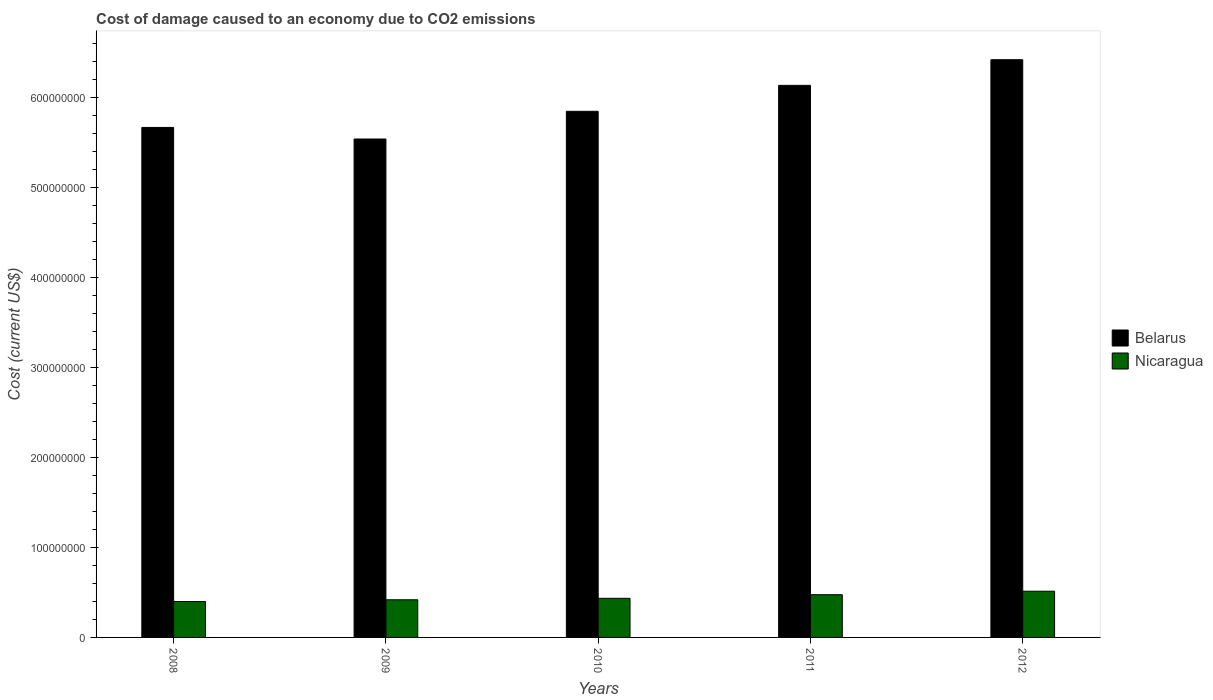How many groups of bars are there?
Give a very brief answer. 5. Are the number of bars per tick equal to the number of legend labels?
Offer a very short reply. Yes. How many bars are there on the 2nd tick from the left?
Make the answer very short. 2. In how many cases, is the number of bars for a given year not equal to the number of legend labels?
Your answer should be very brief. 0. What is the cost of damage caused due to CO2 emissisons in Nicaragua in 2011?
Your response must be concise. 4.75e+07. Across all years, what is the maximum cost of damage caused due to CO2 emissisons in Belarus?
Your answer should be very brief. 6.42e+08. Across all years, what is the minimum cost of damage caused due to CO2 emissisons in Belarus?
Your answer should be compact. 5.54e+08. In which year was the cost of damage caused due to CO2 emissisons in Nicaragua maximum?
Offer a very short reply. 2012. In which year was the cost of damage caused due to CO2 emissisons in Nicaragua minimum?
Provide a succinct answer. 2008. What is the total cost of damage caused due to CO2 emissisons in Belarus in the graph?
Offer a terse response. 2.96e+09. What is the difference between the cost of damage caused due to CO2 emissisons in Nicaragua in 2010 and that in 2011?
Offer a very short reply. -4.03e+06. What is the difference between the cost of damage caused due to CO2 emissisons in Nicaragua in 2008 and the cost of damage caused due to CO2 emissisons in Belarus in 2010?
Your answer should be very brief. -5.45e+08. What is the average cost of damage caused due to CO2 emissisons in Belarus per year?
Your answer should be compact. 5.92e+08. In the year 2008, what is the difference between the cost of damage caused due to CO2 emissisons in Belarus and cost of damage caused due to CO2 emissisons in Nicaragua?
Your answer should be very brief. 5.27e+08. In how many years, is the cost of damage caused due to CO2 emissisons in Belarus greater than 300000000 US$?
Your answer should be compact. 5. What is the ratio of the cost of damage caused due to CO2 emissisons in Nicaragua in 2008 to that in 2012?
Your answer should be compact. 0.78. Is the cost of damage caused due to CO2 emissisons in Belarus in 2009 less than that in 2010?
Make the answer very short. Yes. What is the difference between the highest and the second highest cost of damage caused due to CO2 emissisons in Belarus?
Keep it short and to the point. 2.85e+07. What is the difference between the highest and the lowest cost of damage caused due to CO2 emissisons in Belarus?
Offer a terse response. 8.81e+07. What does the 1st bar from the left in 2011 represents?
Offer a terse response. Belarus. What does the 2nd bar from the right in 2009 represents?
Make the answer very short. Belarus. How many bars are there?
Ensure brevity in your answer.  10. How many years are there in the graph?
Your response must be concise. 5. What is the difference between two consecutive major ticks on the Y-axis?
Make the answer very short. 1.00e+08. Are the values on the major ticks of Y-axis written in scientific E-notation?
Offer a terse response. No. Does the graph contain any zero values?
Offer a terse response. No. Does the graph contain grids?
Give a very brief answer. No. Where does the legend appear in the graph?
Offer a terse response. Center right. How many legend labels are there?
Offer a very short reply. 2. What is the title of the graph?
Provide a succinct answer. Cost of damage caused to an economy due to CO2 emissions. What is the label or title of the X-axis?
Offer a terse response. Years. What is the label or title of the Y-axis?
Provide a short and direct response. Cost (current US$). What is the Cost (current US$) in Belarus in 2008?
Give a very brief answer. 5.67e+08. What is the Cost (current US$) of Nicaragua in 2008?
Ensure brevity in your answer.  3.99e+07. What is the Cost (current US$) in Belarus in 2009?
Give a very brief answer. 5.54e+08. What is the Cost (current US$) of Nicaragua in 2009?
Your answer should be compact. 4.18e+07. What is the Cost (current US$) in Belarus in 2010?
Provide a short and direct response. 5.85e+08. What is the Cost (current US$) of Nicaragua in 2010?
Provide a short and direct response. 4.35e+07. What is the Cost (current US$) in Belarus in 2011?
Your response must be concise. 6.14e+08. What is the Cost (current US$) in Nicaragua in 2011?
Make the answer very short. 4.75e+07. What is the Cost (current US$) in Belarus in 2012?
Make the answer very short. 6.42e+08. What is the Cost (current US$) of Nicaragua in 2012?
Give a very brief answer. 5.14e+07. Across all years, what is the maximum Cost (current US$) of Belarus?
Give a very brief answer. 6.42e+08. Across all years, what is the maximum Cost (current US$) of Nicaragua?
Ensure brevity in your answer.  5.14e+07. Across all years, what is the minimum Cost (current US$) of Belarus?
Your answer should be very brief. 5.54e+08. Across all years, what is the minimum Cost (current US$) in Nicaragua?
Make the answer very short. 3.99e+07. What is the total Cost (current US$) of Belarus in the graph?
Ensure brevity in your answer.  2.96e+09. What is the total Cost (current US$) in Nicaragua in the graph?
Keep it short and to the point. 2.24e+08. What is the difference between the Cost (current US$) in Belarus in 2008 and that in 2009?
Offer a very short reply. 1.29e+07. What is the difference between the Cost (current US$) of Nicaragua in 2008 and that in 2009?
Make the answer very short. -1.94e+06. What is the difference between the Cost (current US$) of Belarus in 2008 and that in 2010?
Provide a succinct answer. -1.79e+07. What is the difference between the Cost (current US$) of Nicaragua in 2008 and that in 2010?
Make the answer very short. -3.55e+06. What is the difference between the Cost (current US$) of Belarus in 2008 and that in 2011?
Offer a terse response. -4.68e+07. What is the difference between the Cost (current US$) in Nicaragua in 2008 and that in 2011?
Provide a short and direct response. -7.58e+06. What is the difference between the Cost (current US$) of Belarus in 2008 and that in 2012?
Offer a very short reply. -7.53e+07. What is the difference between the Cost (current US$) of Nicaragua in 2008 and that in 2012?
Provide a succinct answer. -1.14e+07. What is the difference between the Cost (current US$) in Belarus in 2009 and that in 2010?
Offer a very short reply. -3.08e+07. What is the difference between the Cost (current US$) of Nicaragua in 2009 and that in 2010?
Your answer should be compact. -1.61e+06. What is the difference between the Cost (current US$) of Belarus in 2009 and that in 2011?
Your answer should be very brief. -5.96e+07. What is the difference between the Cost (current US$) in Nicaragua in 2009 and that in 2011?
Ensure brevity in your answer.  -5.64e+06. What is the difference between the Cost (current US$) in Belarus in 2009 and that in 2012?
Provide a short and direct response. -8.81e+07. What is the difference between the Cost (current US$) in Nicaragua in 2009 and that in 2012?
Your response must be concise. -9.51e+06. What is the difference between the Cost (current US$) in Belarus in 2010 and that in 2011?
Keep it short and to the point. -2.88e+07. What is the difference between the Cost (current US$) of Nicaragua in 2010 and that in 2011?
Your answer should be compact. -4.03e+06. What is the difference between the Cost (current US$) of Belarus in 2010 and that in 2012?
Your response must be concise. -5.73e+07. What is the difference between the Cost (current US$) in Nicaragua in 2010 and that in 2012?
Your response must be concise. -7.90e+06. What is the difference between the Cost (current US$) in Belarus in 2011 and that in 2012?
Make the answer very short. -2.85e+07. What is the difference between the Cost (current US$) of Nicaragua in 2011 and that in 2012?
Provide a short and direct response. -3.87e+06. What is the difference between the Cost (current US$) of Belarus in 2008 and the Cost (current US$) of Nicaragua in 2009?
Offer a terse response. 5.25e+08. What is the difference between the Cost (current US$) of Belarus in 2008 and the Cost (current US$) of Nicaragua in 2010?
Keep it short and to the point. 5.23e+08. What is the difference between the Cost (current US$) of Belarus in 2008 and the Cost (current US$) of Nicaragua in 2011?
Ensure brevity in your answer.  5.19e+08. What is the difference between the Cost (current US$) in Belarus in 2008 and the Cost (current US$) in Nicaragua in 2012?
Keep it short and to the point. 5.15e+08. What is the difference between the Cost (current US$) in Belarus in 2009 and the Cost (current US$) in Nicaragua in 2010?
Your answer should be very brief. 5.11e+08. What is the difference between the Cost (current US$) of Belarus in 2009 and the Cost (current US$) of Nicaragua in 2011?
Provide a short and direct response. 5.06e+08. What is the difference between the Cost (current US$) of Belarus in 2009 and the Cost (current US$) of Nicaragua in 2012?
Make the answer very short. 5.03e+08. What is the difference between the Cost (current US$) in Belarus in 2010 and the Cost (current US$) in Nicaragua in 2011?
Offer a terse response. 5.37e+08. What is the difference between the Cost (current US$) in Belarus in 2010 and the Cost (current US$) in Nicaragua in 2012?
Your answer should be compact. 5.33e+08. What is the difference between the Cost (current US$) in Belarus in 2011 and the Cost (current US$) in Nicaragua in 2012?
Keep it short and to the point. 5.62e+08. What is the average Cost (current US$) in Belarus per year?
Provide a succinct answer. 5.92e+08. What is the average Cost (current US$) of Nicaragua per year?
Provide a succinct answer. 4.48e+07. In the year 2008, what is the difference between the Cost (current US$) in Belarus and Cost (current US$) in Nicaragua?
Your answer should be very brief. 5.27e+08. In the year 2009, what is the difference between the Cost (current US$) of Belarus and Cost (current US$) of Nicaragua?
Keep it short and to the point. 5.12e+08. In the year 2010, what is the difference between the Cost (current US$) of Belarus and Cost (current US$) of Nicaragua?
Your answer should be compact. 5.41e+08. In the year 2011, what is the difference between the Cost (current US$) of Belarus and Cost (current US$) of Nicaragua?
Make the answer very short. 5.66e+08. In the year 2012, what is the difference between the Cost (current US$) of Belarus and Cost (current US$) of Nicaragua?
Keep it short and to the point. 5.91e+08. What is the ratio of the Cost (current US$) in Belarus in 2008 to that in 2009?
Ensure brevity in your answer.  1.02. What is the ratio of the Cost (current US$) of Nicaragua in 2008 to that in 2009?
Offer a terse response. 0.95. What is the ratio of the Cost (current US$) in Belarus in 2008 to that in 2010?
Your answer should be very brief. 0.97. What is the ratio of the Cost (current US$) in Nicaragua in 2008 to that in 2010?
Provide a succinct answer. 0.92. What is the ratio of the Cost (current US$) of Belarus in 2008 to that in 2011?
Your answer should be compact. 0.92. What is the ratio of the Cost (current US$) of Nicaragua in 2008 to that in 2011?
Provide a succinct answer. 0.84. What is the ratio of the Cost (current US$) of Belarus in 2008 to that in 2012?
Ensure brevity in your answer.  0.88. What is the ratio of the Cost (current US$) of Nicaragua in 2008 to that in 2012?
Offer a very short reply. 0.78. What is the ratio of the Cost (current US$) of Belarus in 2009 to that in 2010?
Your answer should be very brief. 0.95. What is the ratio of the Cost (current US$) of Nicaragua in 2009 to that in 2010?
Make the answer very short. 0.96. What is the ratio of the Cost (current US$) of Belarus in 2009 to that in 2011?
Offer a very short reply. 0.9. What is the ratio of the Cost (current US$) of Nicaragua in 2009 to that in 2011?
Ensure brevity in your answer.  0.88. What is the ratio of the Cost (current US$) of Belarus in 2009 to that in 2012?
Give a very brief answer. 0.86. What is the ratio of the Cost (current US$) in Nicaragua in 2009 to that in 2012?
Give a very brief answer. 0.81. What is the ratio of the Cost (current US$) in Belarus in 2010 to that in 2011?
Your answer should be compact. 0.95. What is the ratio of the Cost (current US$) in Nicaragua in 2010 to that in 2011?
Offer a terse response. 0.92. What is the ratio of the Cost (current US$) of Belarus in 2010 to that in 2012?
Give a very brief answer. 0.91. What is the ratio of the Cost (current US$) in Nicaragua in 2010 to that in 2012?
Offer a terse response. 0.85. What is the ratio of the Cost (current US$) in Belarus in 2011 to that in 2012?
Keep it short and to the point. 0.96. What is the ratio of the Cost (current US$) in Nicaragua in 2011 to that in 2012?
Ensure brevity in your answer.  0.92. What is the difference between the highest and the second highest Cost (current US$) in Belarus?
Your answer should be compact. 2.85e+07. What is the difference between the highest and the second highest Cost (current US$) of Nicaragua?
Offer a very short reply. 3.87e+06. What is the difference between the highest and the lowest Cost (current US$) in Belarus?
Offer a very short reply. 8.81e+07. What is the difference between the highest and the lowest Cost (current US$) of Nicaragua?
Keep it short and to the point. 1.14e+07. 